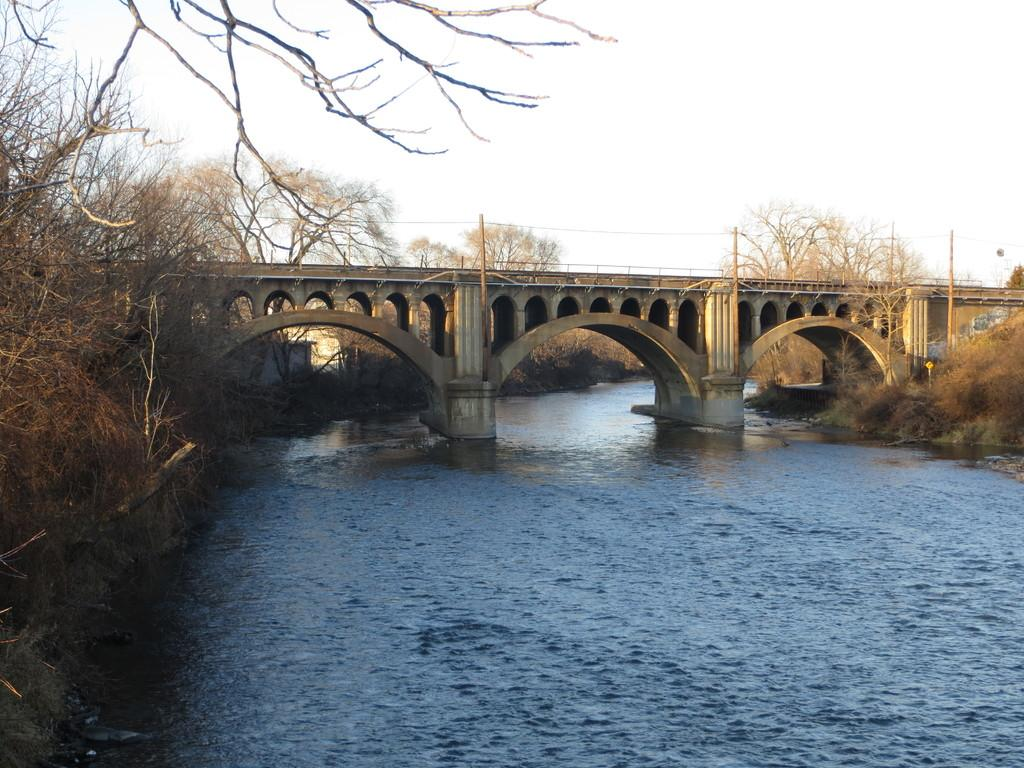What is one of the main elements in the image? There is water in the image. What type of natural vegetation can be seen in the image? There are trees in the image. What structures are present in the image? There are poles and a bridge in the image. What else can be seen in the image? There are wires in the image. What is visible at the top of the image? The sky is visible at the top of the image. Based on the lighting and visibility, when do you think the image was taken? The image was likely taken during the day. What type of seed can be seen in the image? There is no seed present in the image. 